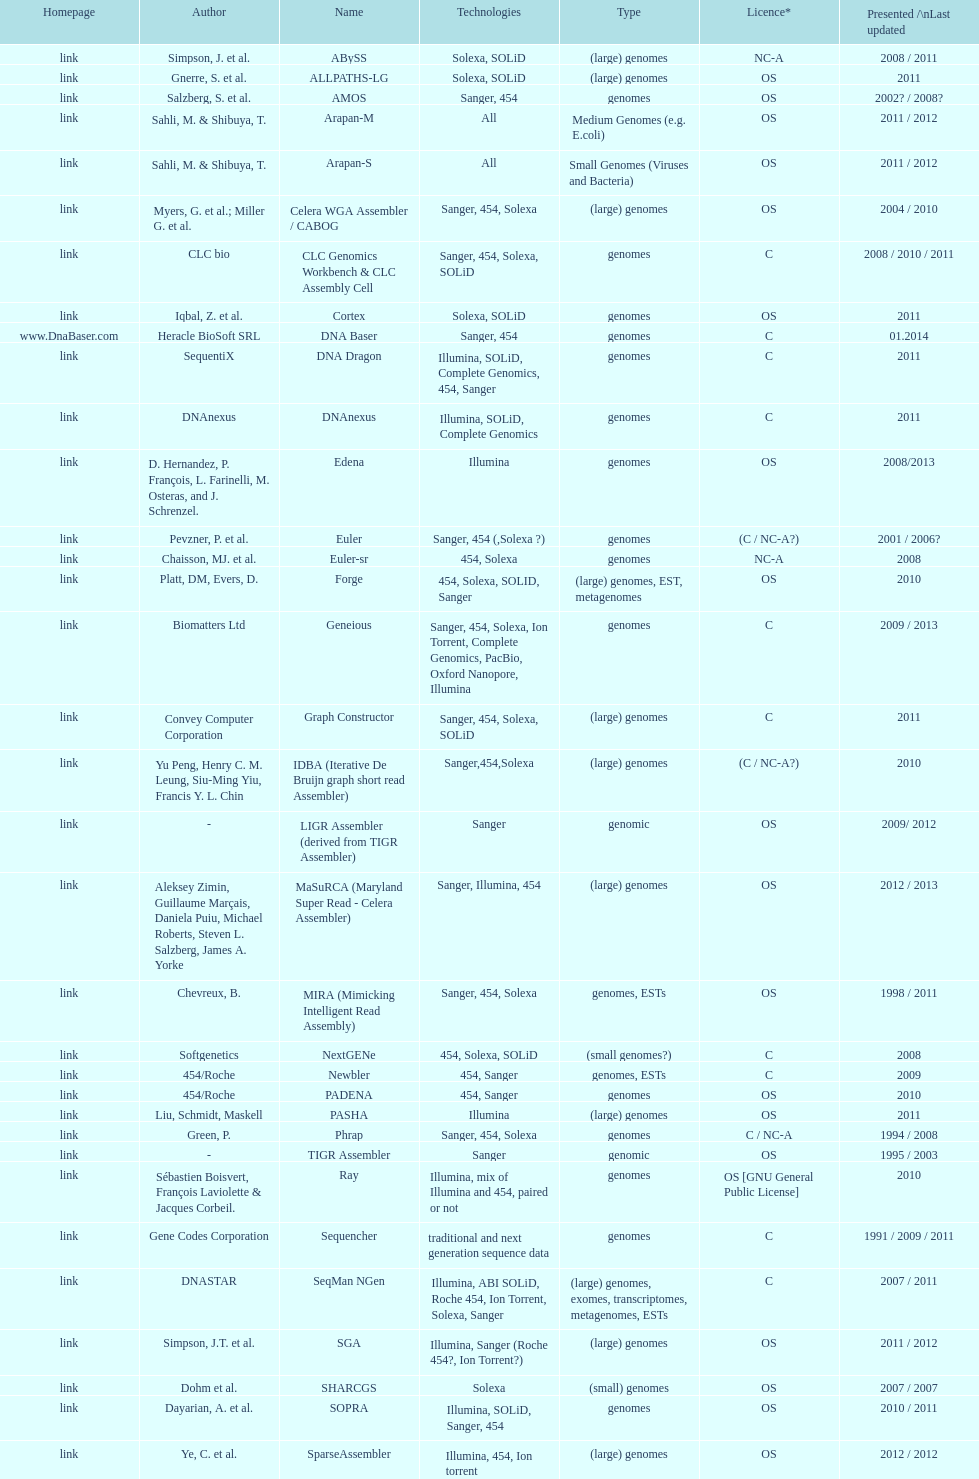When was the velvet last updated? 2009. 